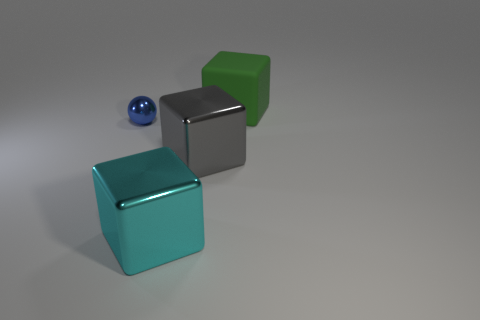Are there any other things that have the same size as the metallic sphere?
Keep it short and to the point. No. What shape is the metallic thing that is on the left side of the big shiny object in front of the large shiny block on the right side of the big cyan block?
Offer a very short reply. Sphere. What shape is the large object behind the blue shiny ball?
Offer a very short reply. Cube. Does the gray cube have the same material as the blue ball that is behind the big cyan metallic cube?
Keep it short and to the point. Yes. How many other objects are the same shape as the gray shiny thing?
Your answer should be very brief. 2. Are there any other things that have the same material as the ball?
Make the answer very short. Yes. The shiny thing that is left of the metal cube that is to the left of the big gray shiny block is what shape?
Make the answer very short. Sphere. There is a thing that is behind the tiny blue object; is its shape the same as the big gray metallic thing?
Provide a succinct answer. Yes. Is the number of blocks that are in front of the green matte cube greater than the number of small spheres right of the blue metal thing?
Offer a terse response. Yes. What number of large gray metal things are right of the large thing that is right of the big gray metallic cube?
Make the answer very short. 0. 